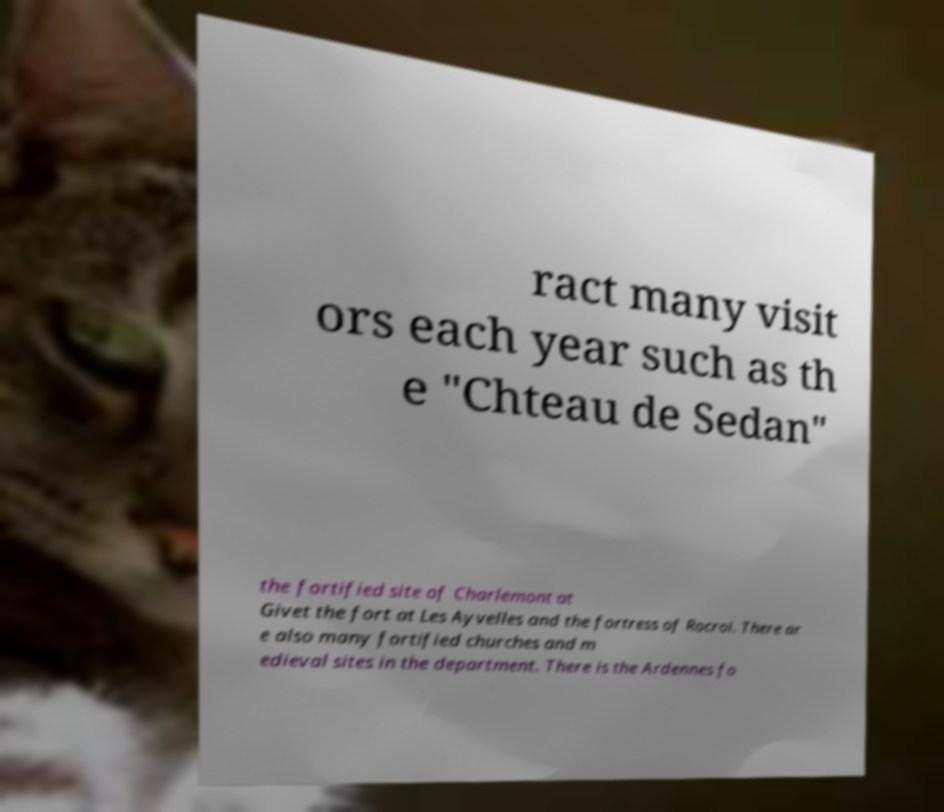There's text embedded in this image that I need extracted. Can you transcribe it verbatim? ract many visit ors each year such as th e "Chteau de Sedan" the fortified site of Charlemont at Givet the fort at Les Ayvelles and the fortress of Rocroi. There ar e also many fortified churches and m edieval sites in the department. There is the Ardennes fo 